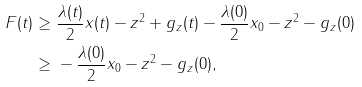Convert formula to latex. <formula><loc_0><loc_0><loc_500><loc_500>F ( t ) \geq & \ \frac { \lambda ( t ) } { 2 } \| x ( t ) - z \| ^ { 2 } + g _ { z } ( t ) - \frac { \lambda ( 0 ) } { 2 } \| x _ { 0 } - z \| ^ { 2 } - g _ { z } ( 0 ) \\ \geq & \ - \frac { \lambda ( 0 ) } { 2 } \| x _ { 0 } - z \| ^ { 2 } - g _ { z } ( 0 ) ,</formula> 